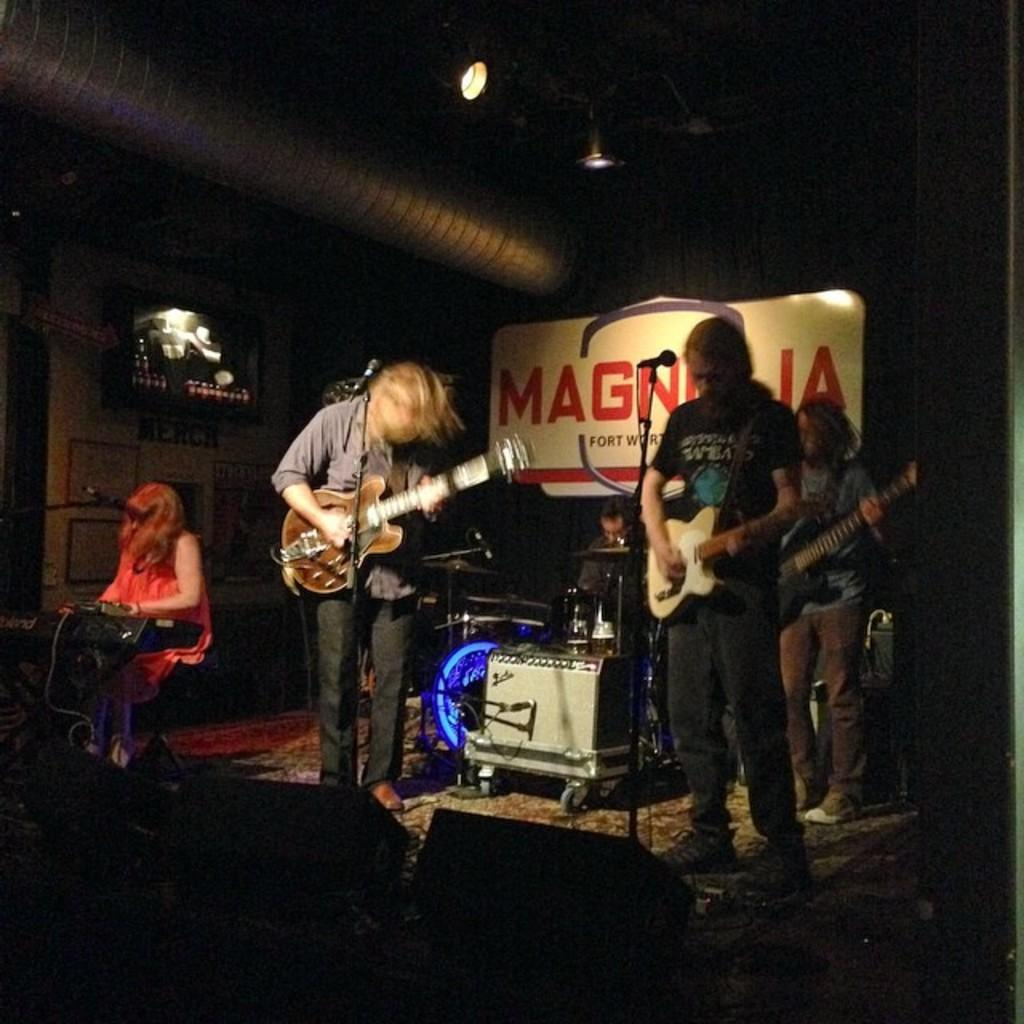What are the men in the image holding? The men in the image are holding guitars. What is the woman in the image doing? The woman is playing music in the image. What instrument is the man at the back playing? The man at the back is playing drums in the image. What type of pest can be seen crawling on the guitar in the image? There are no pests visible in the image; the men are holding guitars without any pests present. What liquid is being used to play the drums in the image? There is no liquid involved in playing the drums in the image; the man is playing the drums with drumsticks. 